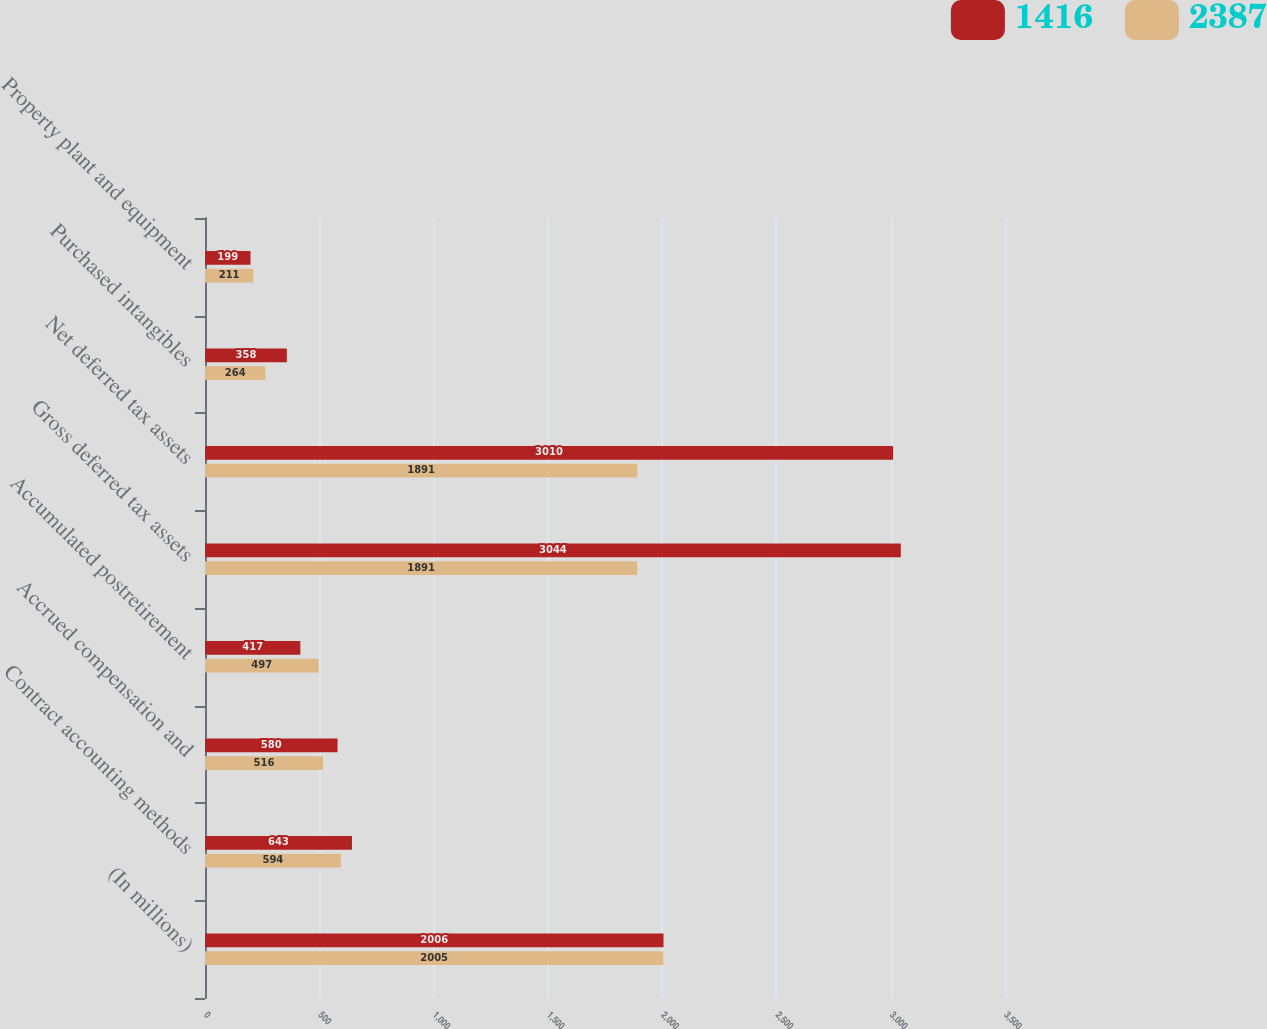Convert chart to OTSL. <chart><loc_0><loc_0><loc_500><loc_500><stacked_bar_chart><ecel><fcel>(In millions)<fcel>Contract accounting methods<fcel>Accrued compensation and<fcel>Accumulated postretirement<fcel>Gross deferred tax assets<fcel>Net deferred tax assets<fcel>Purchased intangibles<fcel>Property plant and equipment<nl><fcel>1416<fcel>2006<fcel>643<fcel>580<fcel>417<fcel>3044<fcel>3010<fcel>358<fcel>199<nl><fcel>2387<fcel>2005<fcel>594<fcel>516<fcel>497<fcel>1891<fcel>1891<fcel>264<fcel>211<nl></chart> 